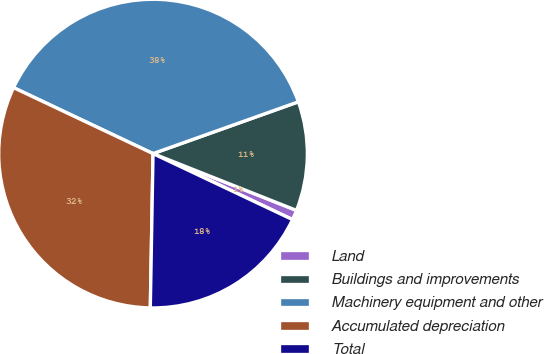<chart> <loc_0><loc_0><loc_500><loc_500><pie_chart><fcel>Land<fcel>Buildings and improvements<fcel>Machinery equipment and other<fcel>Accumulated depreciation<fcel>Total<nl><fcel>1.03%<fcel>11.45%<fcel>37.52%<fcel>31.75%<fcel>18.25%<nl></chart> 